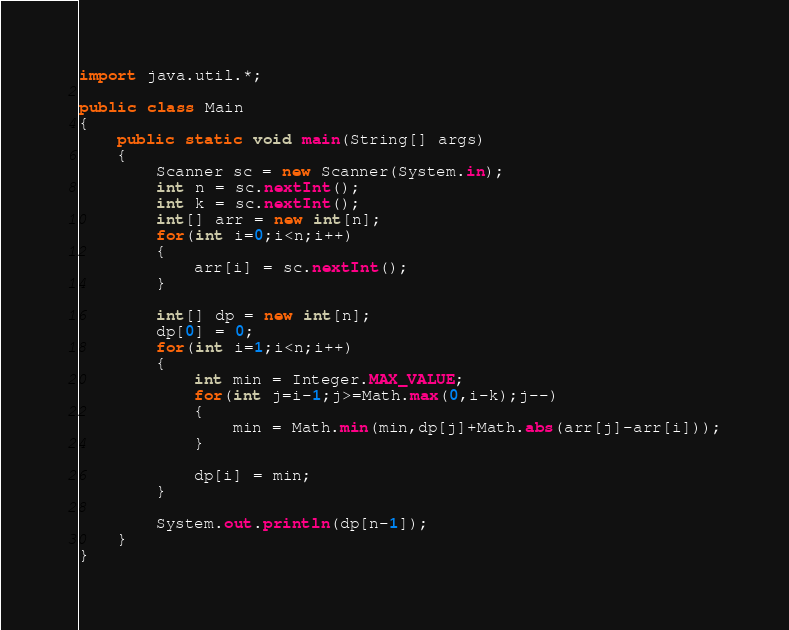<code> <loc_0><loc_0><loc_500><loc_500><_Java_>import java.util.*;

public class Main
{
	public static void main(String[] args)
	{
		Scanner sc = new Scanner(System.in);
		int n = sc.nextInt();
		int k = sc.nextInt();
		int[] arr = new int[n];
		for(int i=0;i<n;i++)
		{
			arr[i] = sc.nextInt();
		}

		int[] dp = new int[n];
		dp[0] = 0;
		for(int i=1;i<n;i++)
		{
			int min = Integer.MAX_VALUE;
			for(int j=i-1;j>=Math.max(0,i-k);j--)
			{
				min = Math.min(min,dp[j]+Math.abs(arr[j]-arr[i]));
			}

			dp[i] = min;
		}

		System.out.println(dp[n-1]);
	}
}</code> 